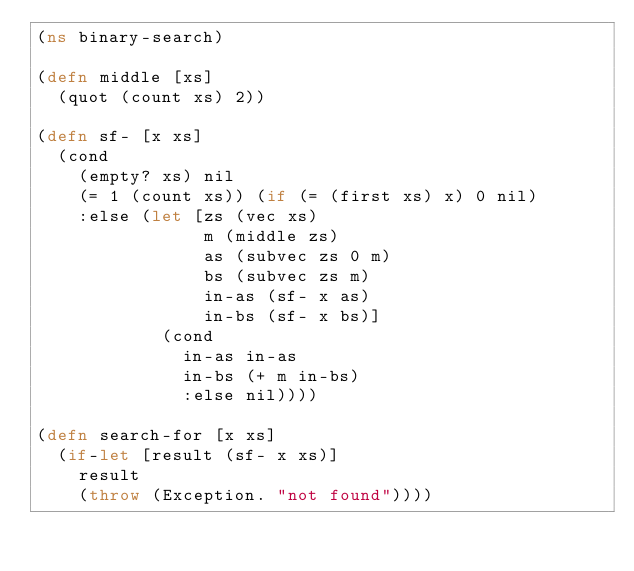Convert code to text. <code><loc_0><loc_0><loc_500><loc_500><_Clojure_>(ns binary-search)

(defn middle [xs]
  (quot (count xs) 2))

(defn sf- [x xs]
  (cond
    (empty? xs) nil
    (= 1 (count xs)) (if (= (first xs) x) 0 nil)
    :else (let [zs (vec xs)
                m (middle zs)
                as (subvec zs 0 m)
                bs (subvec zs m)
                in-as (sf- x as)
                in-bs (sf- x bs)]
            (cond
              in-as in-as
              in-bs (+ m in-bs)
              :else nil))))

(defn search-for [x xs]
  (if-let [result (sf- x xs)]
    result
    (throw (Exception. "not found"))))

</code> 